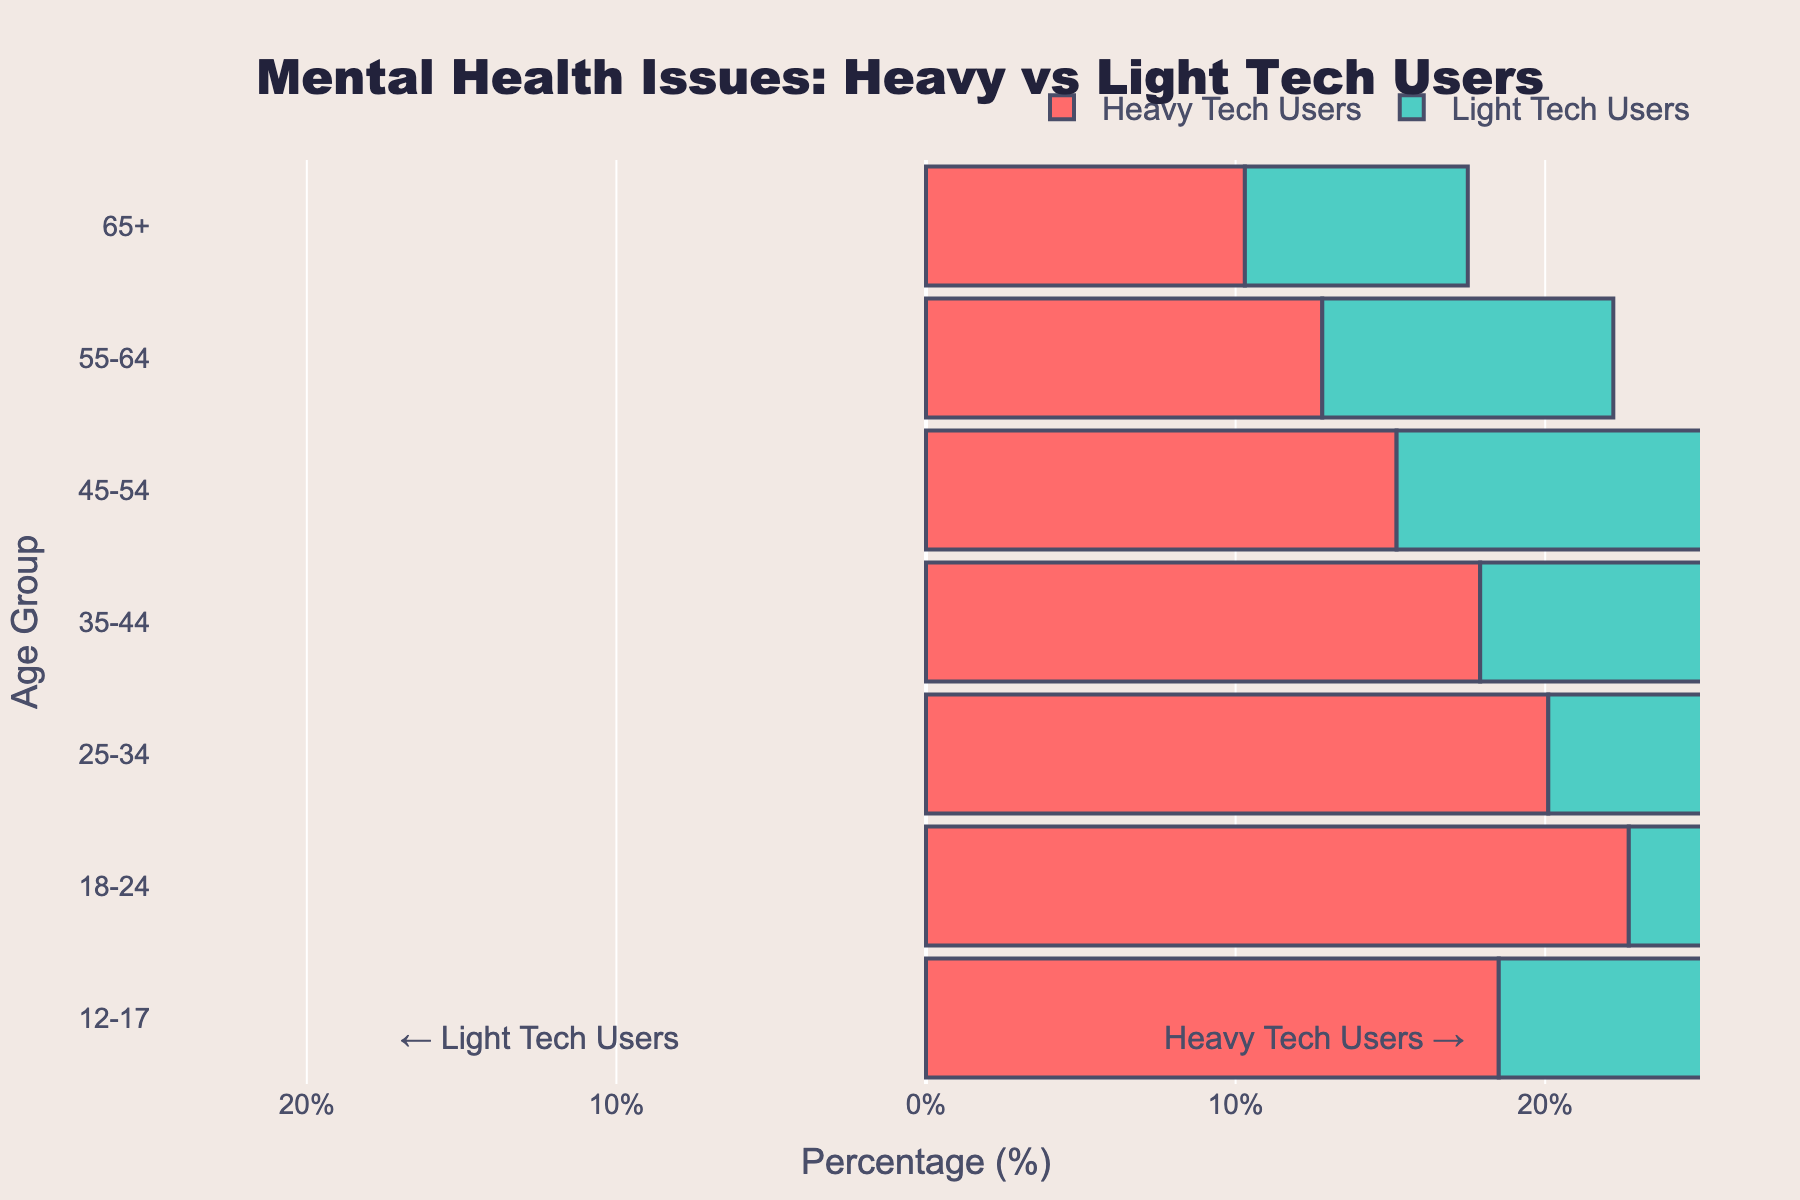What is the title of the figure? The title is located at the top center of the figure and summarizes the dataset.
Answer: Mental Health Issues: Heavy vs Light Tech Users What are the age groups listed on the y-axis? The y-axis displays the categories for different age groups. By reading these labels, we find they range from "12-17" to "65+".
Answer: 12-17, 18-24, 25-34, 35-44, 45-54, 55-64, 65+ Which group has a higher percentage of reported mental health issues in the 25-34 age group? By observing the bars corresponding to the 25-34 age group, the bar representing heavy tech users is higher than the one representing light tech users.
Answer: Heavy Tech Users What is the percentage of mental health issues reported by heavy tech users in the 18-24 age group? By reading the length of the bar corresponding to heavy tech users in the 18-24 age group, we see the value is labeled.
Answer: 22.7% How does the percentage of reported mental health issues for light tech users change from the 12-17 age group to the 65+ age group? By comparing the lengths of the bars for light tech users across these age groups, we observe the percentage increases from -12.3% to -7.2%.
Answer: Increases Which age group has the smallest difference in the percentage of reported mental health issues between heavy tech users and light tech users? By calculating the absolute difference between the bars for each age group, the 65+ group has the smallest difference (10.3% - 7.2%).
Answer: 65+ What is the average percentage of mental health issues reported by heavy tech users across all age groups? By summing the percentages for heavy tech users and dividing by the number of age groups, (18.5 + 22.7 + 20.1 + 17.9 + 15.2 + 12.8 + 10.3) / 7 ≈ 16.79%.
Answer: 16.79% What is the trend in reported mental health issue percentages for heavy tech users as age increases? By examining the bars for heavy tech users from the youngest age group to the oldest, we see that the percentages generally decrease.
Answer: Decreases Which age group exhibits the largest percentage difference in reported mental health issues between heavy and light tech users? By calculating the absolute difference between heavy and light tech users percentages for each age group, the 25-34 group has the largest difference (20.1% - 15.8% = 35.9%).
Answer: 25-34 